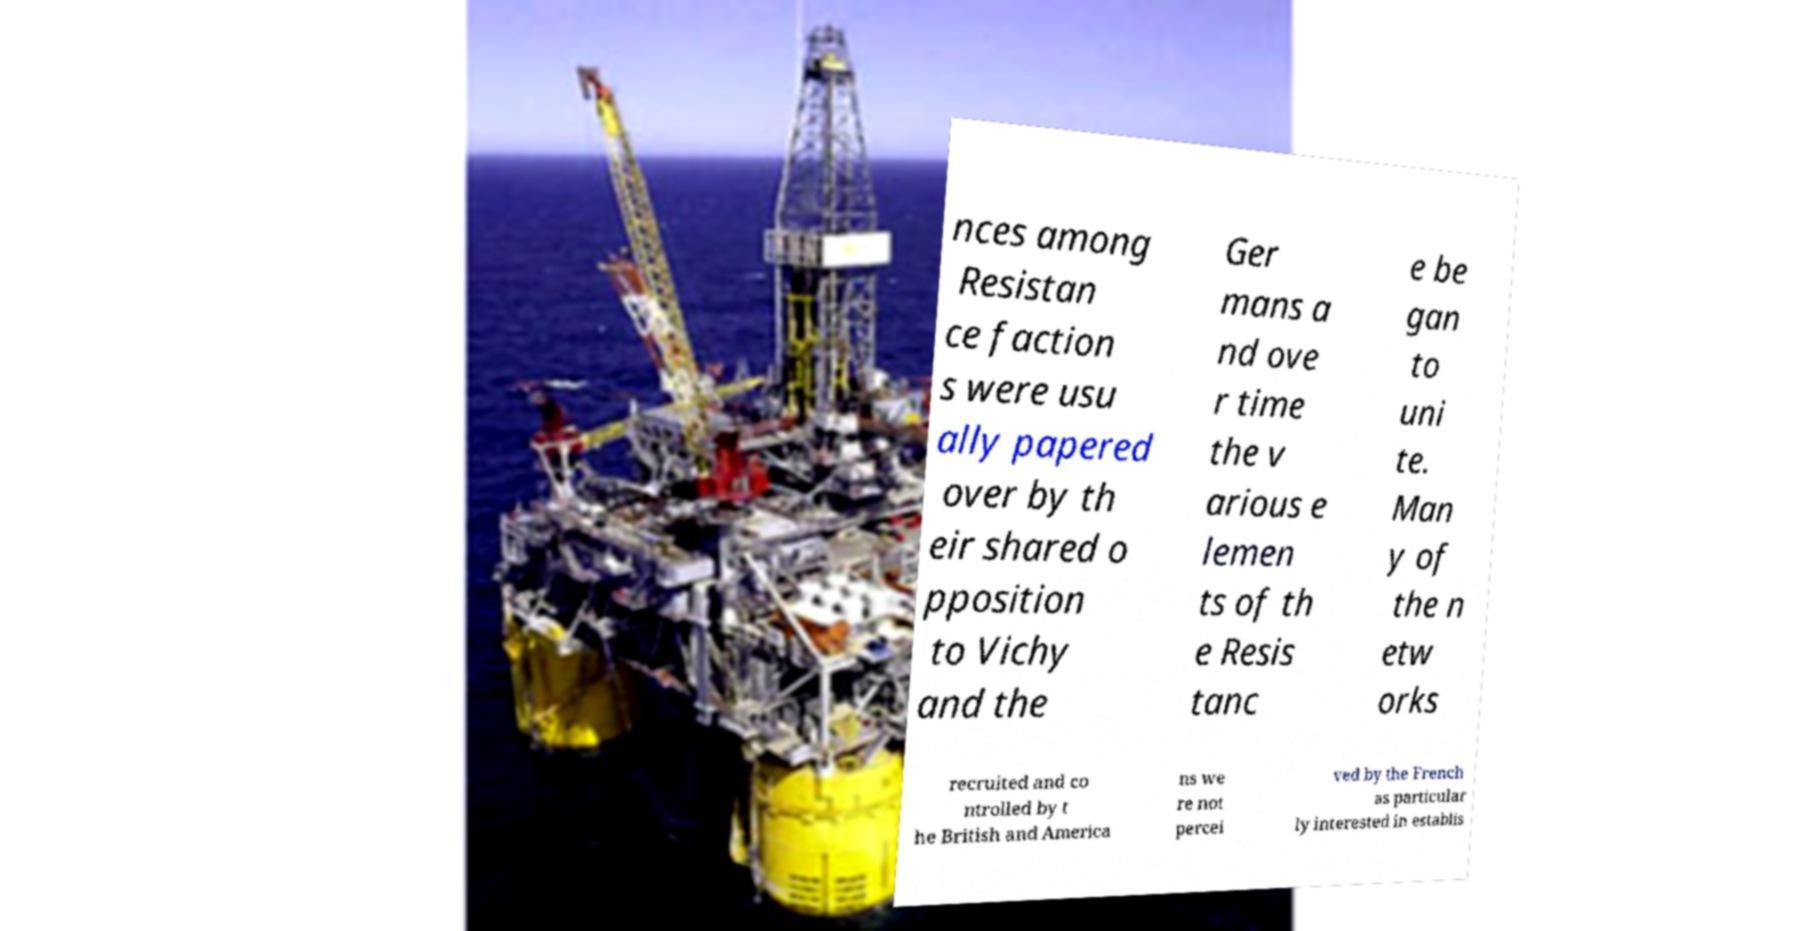Please identify and transcribe the text found in this image. nces among Resistan ce faction s were usu ally papered over by th eir shared o pposition to Vichy and the Ger mans a nd ove r time the v arious e lemen ts of th e Resis tanc e be gan to uni te. Man y of the n etw orks recruited and co ntrolled by t he British and America ns we re not percei ved by the French as particular ly interested in establis 